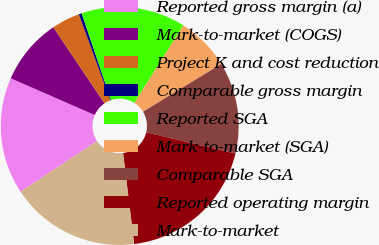Convert chart to OTSL. <chart><loc_0><loc_0><loc_500><loc_500><pie_chart><fcel>Reported gross margin (a)<fcel>Mark-to-market (COGS)<fcel>Project K and cost reduction<fcel>Comparable gross margin<fcel>Reported SGA<fcel>Mark-to-market (SGA)<fcel>Comparable SGA<fcel>Reported operating margin<fcel>Mark-to-market<nl><fcel>15.89%<fcel>9.01%<fcel>3.84%<fcel>0.4%<fcel>14.17%<fcel>7.29%<fcel>12.45%<fcel>19.34%<fcel>17.61%<nl></chart> 